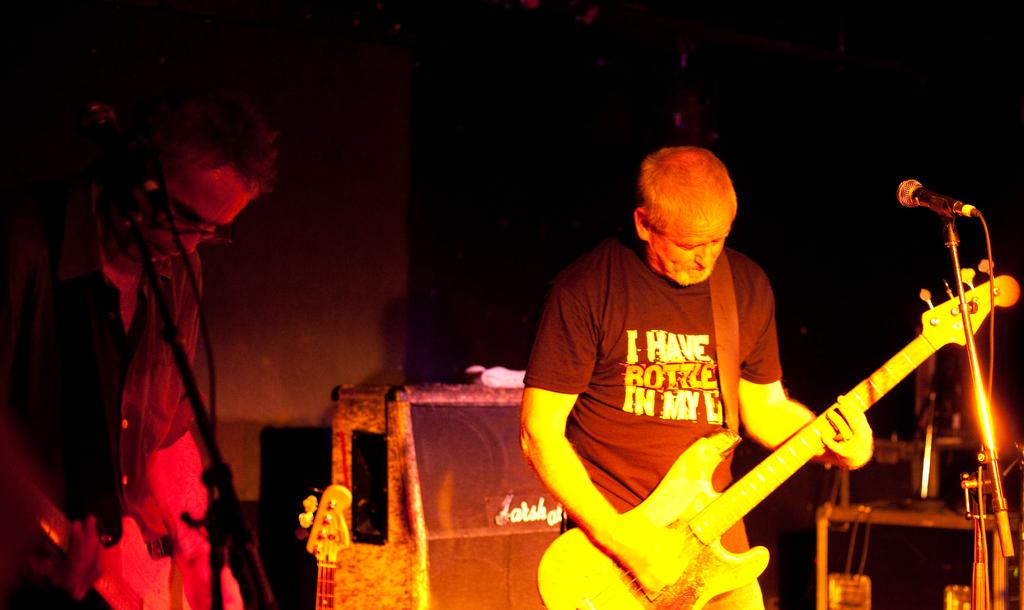What is the man on the stage doing? The man on the stage is playing a guitar. Who else is present near the stage? There is a person standing at the side of the stage. What is the man on the stage using to amplify his voice? There is a microphone and stand in the image. What other objects can be seen in the image? There are some objects present in the image. What is the price of the account the man is singing about in the image? There is no mention of an account or any singing in the image; the man is playing a guitar. 